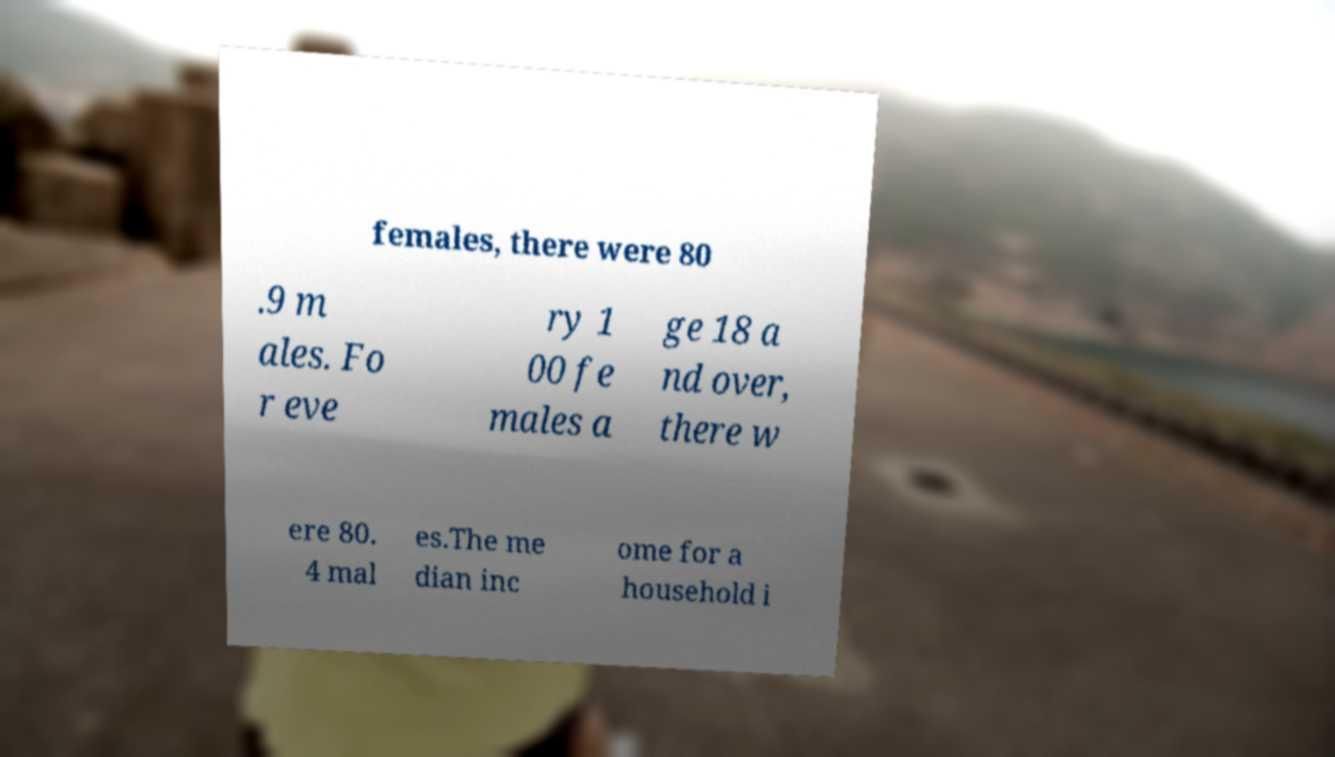Can you read and provide the text displayed in the image?This photo seems to have some interesting text. Can you extract and type it out for me? females, there were 80 .9 m ales. Fo r eve ry 1 00 fe males a ge 18 a nd over, there w ere 80. 4 mal es.The me dian inc ome for a household i 